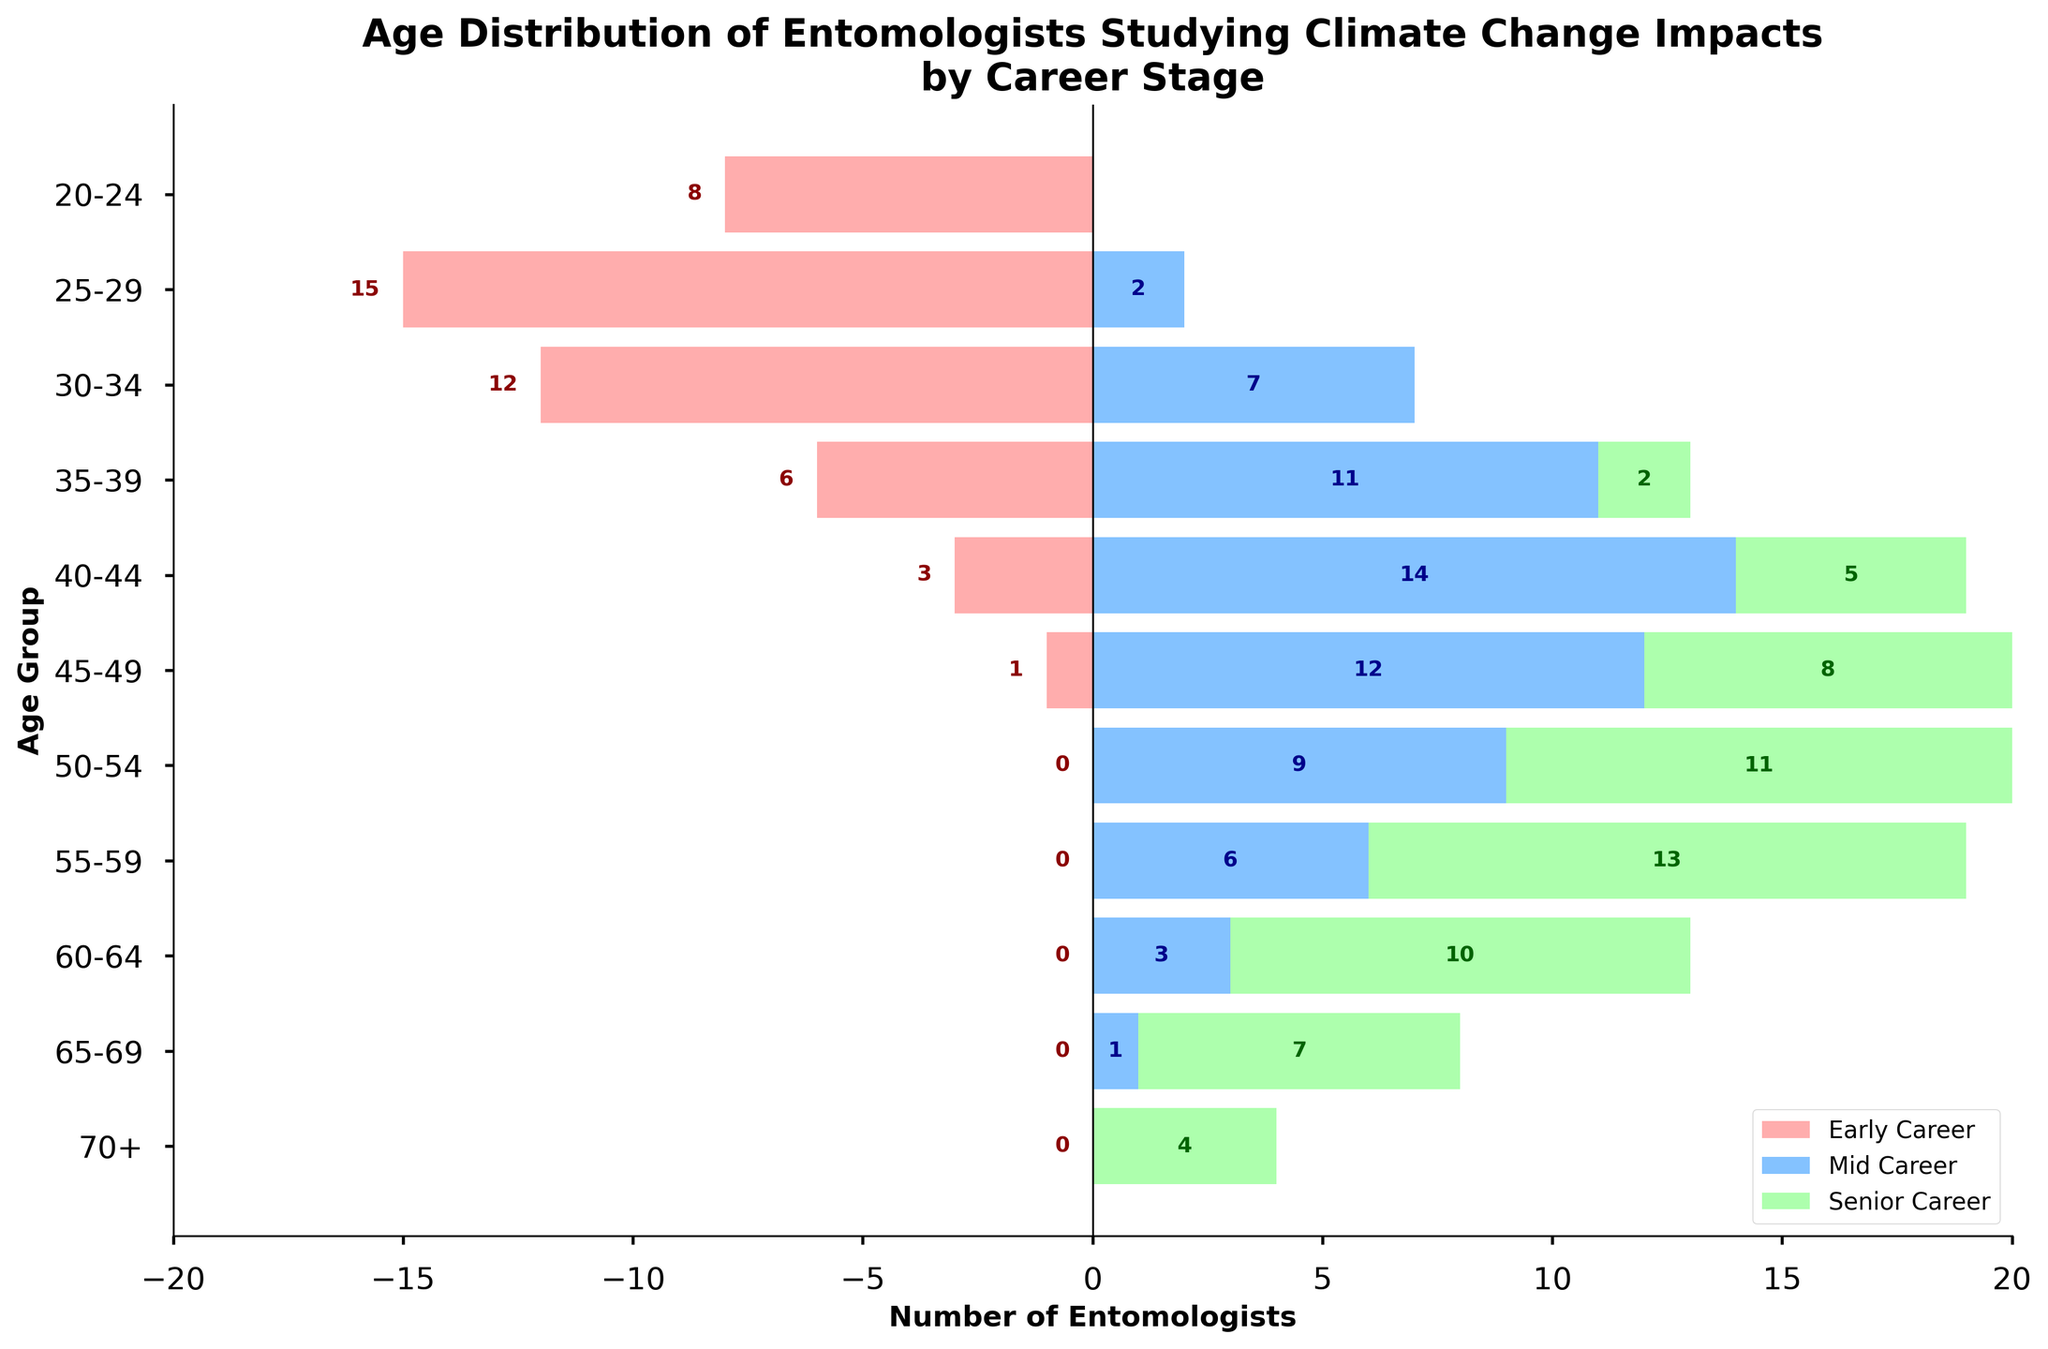What is the title of the figure? The title of the figure is prominently displayed at the top.
Answer: Age Distribution of Entomologists Studying Climate Change Impacts by Career Stage How many entomologists are in the Early Career stage in the 25-29 age group? The number of entomologists is clearly marked inside the red bar corresponding to the 25-29 age group for the Early Career stage.
Answer: 15 What is the total number of Senior Career entomologists in the 60-64 age group? The number of Senior Career entomologists is shown inside the green bar associated with the 60-64 age group.
Answer: 10 How many Mid Career entomologists are there between the ages of 40-44? The number of Mid Career entomologists is noted inside the blue bar for the 40-44 age group.
Answer: 14 Which career stage has the highest number of entomologists in the 35-39 age group? To find the answer, compare the lengths of the bars representing Early Career, Mid Career, and Senior Career in the 35-39 age group.
Answer: Mid Career What is the difference between the number of Early Career and Senior Career entomologists in the 45-49 age group? Subtract the number of Senior Career entomologists (orange bar) from the number of Early Career entomologists (red bar) in the 45-49 age group.
Answer: -7 Among entomologists aged 55-59, who has a higher number, Mid Career or Senior Career? To determine this, compare the lengths of the blue and green bars for the 55-59 age group.
Answer: Senior Career What is the sum of Early Career and Senior Career entomologists in the 30-34 age group? Add the number of Early Career entomologists to the number of Senior Career entomologists in the 30-34 age group.
Answer: 12 Which age group has no Early Career entomologists? Identify the age group where the red bar representing Early Career entomologists has a value of zero.
Answer: 50+ In the 70+ age group, how many more Senior Career entomologists are there than Mid Career entomologists? Compare the values for Senior Career and Mid Career entomologists in the 70+ age group and find the difference.
Answer: 4 